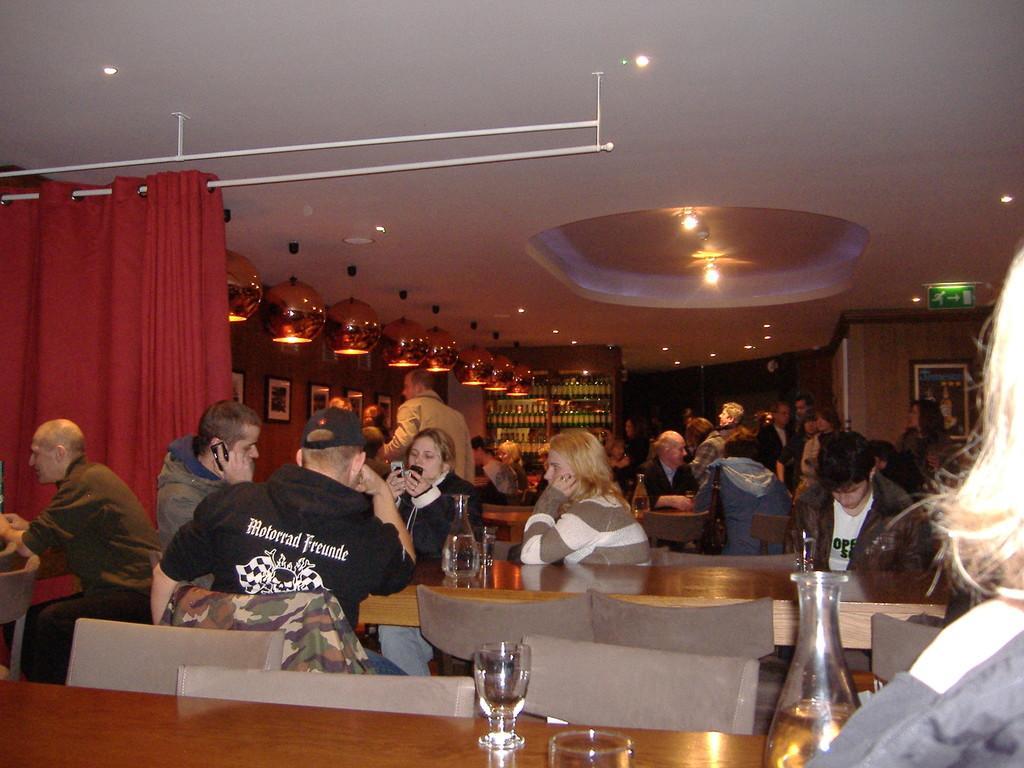Can you describe this image briefly? At the top we can see ceiling and lights. On the background we can see frames on a wall and bottles arranged in a rack. This is a sign board. Here we can see few persons standing on the floor. All the persons sitting on chairs in front of a table and on the table we can see glasses, bottles. This is a red colour curtain. 